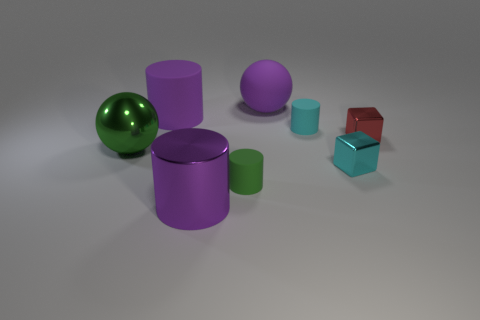There is a sphere that is left of the large ball right of the small green object; what number of big metal cylinders are in front of it?
Keep it short and to the point. 1. There is a large purple shiny thing; are there any cyan shiny objects to the right of it?
Give a very brief answer. Yes. Is there anything else that is the same color as the big metallic cylinder?
Provide a short and direct response. Yes. What number of balls are cyan metallic objects or red shiny things?
Your response must be concise. 0. How many things are both in front of the big purple rubber cylinder and on the right side of the tiny green rubber cylinder?
Keep it short and to the point. 3. Are there the same number of small cyan things that are to the left of the cyan metallic object and cyan cubes that are behind the big purple rubber cylinder?
Keep it short and to the point. No. Is the shape of the big object in front of the cyan cube the same as  the small green object?
Provide a short and direct response. Yes. What shape is the tiny metal thing that is behind the sphere in front of the big sphere behind the green metallic thing?
Your response must be concise. Cube. There is a large shiny thing that is the same color as the large rubber ball; what shape is it?
Give a very brief answer. Cylinder. What material is the tiny object that is on the right side of the cyan cylinder and in front of the small red metal thing?
Ensure brevity in your answer.  Metal. 